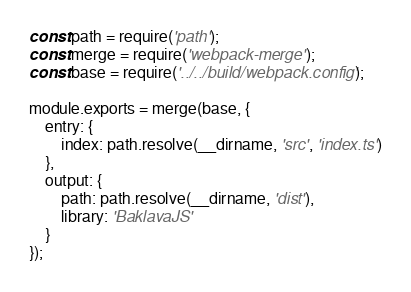Convert code to text. <code><loc_0><loc_0><loc_500><loc_500><_JavaScript_>const path = require('path');
const merge = require('webpack-merge');
const base = require('../../build/webpack.config');

module.exports = merge(base, {
    entry: {
        index: path.resolve(__dirname, 'src', 'index.ts')
    },
    output: {
        path: path.resolve(__dirname, 'dist'),
        library: 'BaklavaJS'
    }
});
</code> 